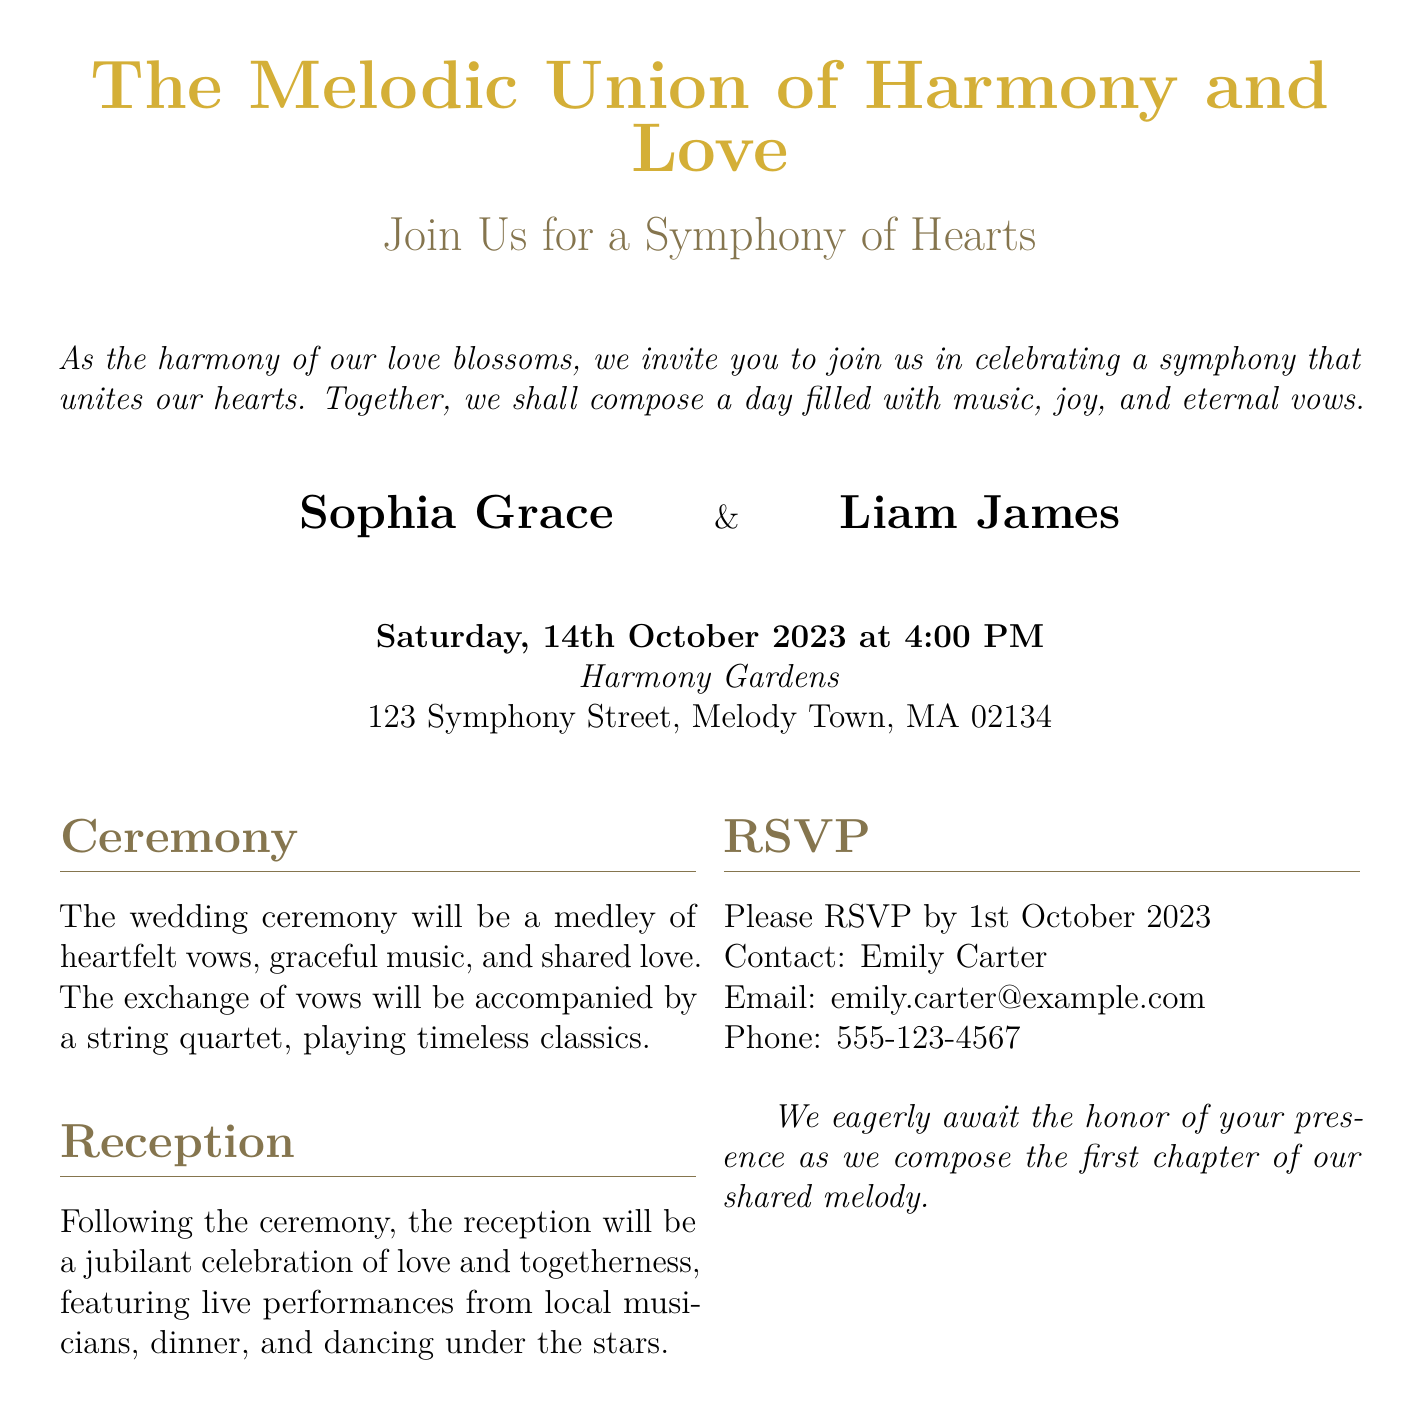What are the names of the couple? The names of the couple are presented prominently in the invitation, highlighting the individuals getting married.
Answer: Sophia Grace & Liam James When is the wedding ceremony scheduled? The date of the wedding ceremony is explicitly stated in the invitation, indicating when the event will take place.
Answer: Saturday, 14th October 2023 Where is the wedding ceremony taking place? The location of the wedding ceremony is clearly mentioned in the document, providing the address for the guests.
Answer: Harmony Gardens, 123 Symphony Street, Melody Town, MA 02134 What is the RSVP deadline? The deadline for guests to RSVP is specifically noted in the document, indicating the last date for confirmations.
Answer: 1st October 2023 What type of music will accompany the exchange of vows? The document describes the musical accompaniment during the exchange of vows, detailing what guests can expect during the ceremony.
Answer: String quartet What will happen after the ceremony? The invitation outlines the events following the ceremony, describing what guests can look forward to during the celebration.
Answer: Reception Who should guests contact for RSVP? The document provides specific contact information for guests to reach out for RSVP inquiries.
Answer: Emily Carter What will the reception feature? The invitation describes the offerings during the reception, providing an idea of the celebration's atmosphere.
Answer: Live performances from local musicians, dinner, and dancing under the stars 